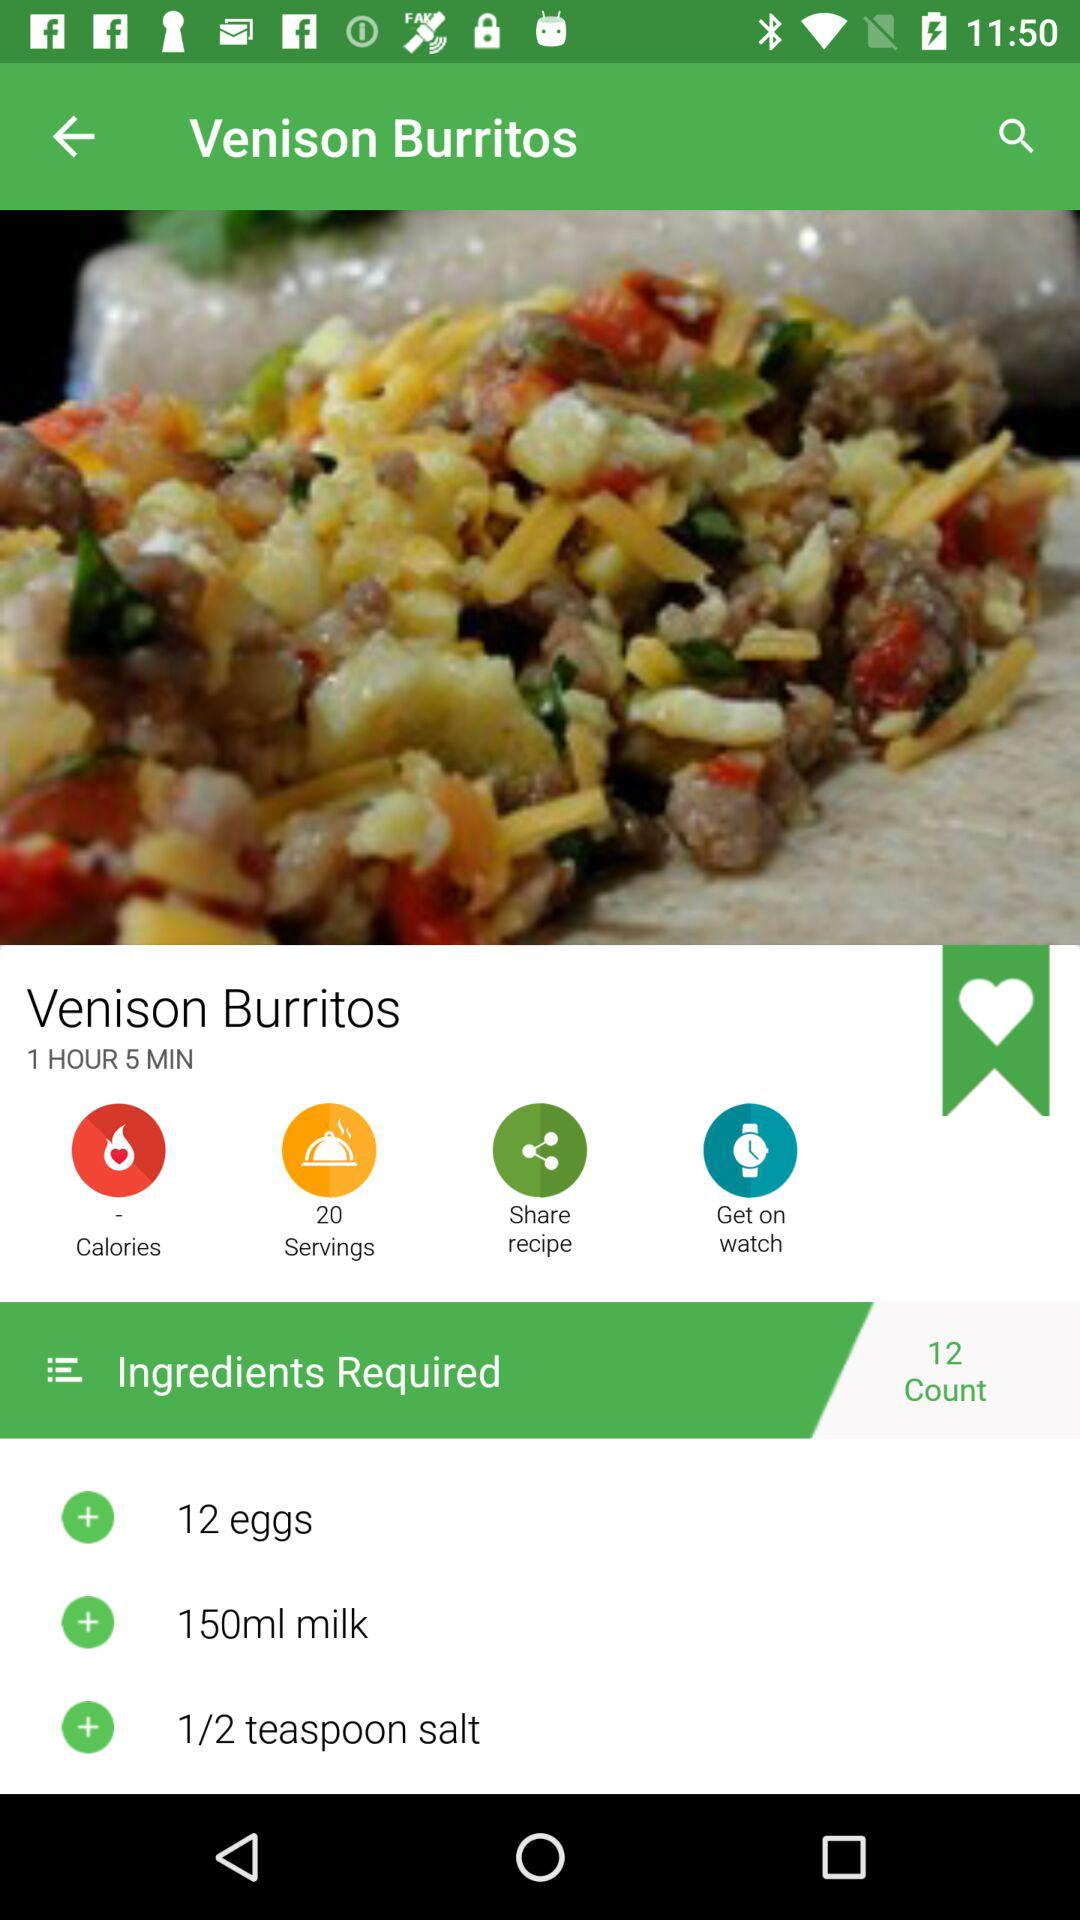How much salt is required?
Answer the question using a single word or phrase. 1/2 teaspoon 